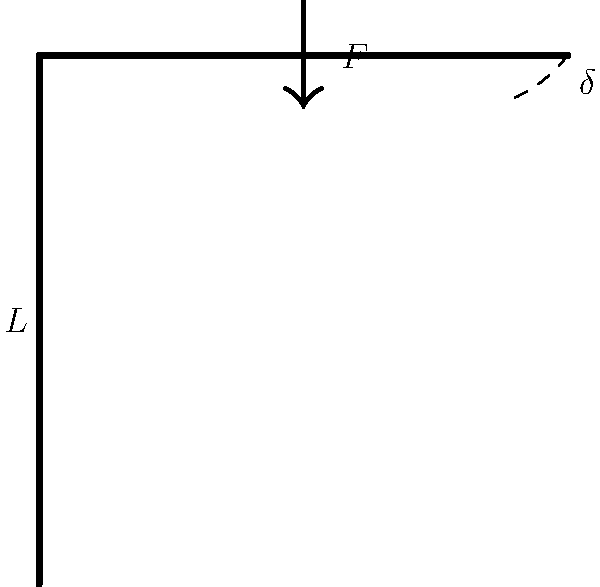Consider a soccer goal post subjected to a force $F$ at the top corner, causing it to deflect. If the post has a length $L$ and experiences a deflection $\delta$ at the top, what is the maximum strain experienced by the post? Assume the post behaves as a cantilever beam with a circular cross-section. To solve this problem, we'll follow these steps:

1. Recognize that the maximum strain occurs at the base of the post where bending stress is highest.

2. For a cantilever beam with a force applied at the free end, the maximum deflection $\delta$ is given by:

   $$\delta = \frac{F L^3}{3EI}$$

   where $E$ is the Young's modulus and $I$ is the moment of inertia.

3. The maximum bending stress $\sigma_{max}$ occurs at the outer fibers of the base and is given by:

   $$\sigma_{max} = \frac{M c}{I}$$

   where $M$ is the bending moment, $c$ is the distance from the neutral axis to the outer fiber.

4. For a cantilever beam with a force at the free end, $M = F L$ at the base.

5. The strain $\epsilon$ is related to stress by Hooke's law:

   $$\epsilon = \frac{\sigma}{E}$$

6. Substituting the expression for $\sigma_{max}$ into Hooke's law:

   $$\epsilon_{max} = \frac{\sigma_{max}}{E} = \frac{M c}{E I} = \frac{F L c}{E I}$$

7. From step 2, we can express $F$ in terms of $\delta$:

   $$F = \frac{3 E I \delta}{L^3}$$

8. Substituting this into the expression for $\epsilon_{max}$:

   $$\epsilon_{max} = \frac{3 E I \delta}{L^3} \cdot \frac{L c}{E I} = \frac{3 c \delta}{L^2}$$

9. For a circular cross-section, $c$ is equal to the radius $r$, which is half the diameter $d$:

   $$\epsilon_{max} = \frac{3 d \delta}{2 L^2}$$

This final expression gives the maximum strain in terms of the post's geometry and deflection.
Answer: $\epsilon_{max} = \frac{3 d \delta}{2 L^2}$ 